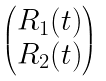<formula> <loc_0><loc_0><loc_500><loc_500>\begin{pmatrix} R _ { 1 } ( t ) \\ R _ { 2 } ( t ) \end{pmatrix}</formula> 